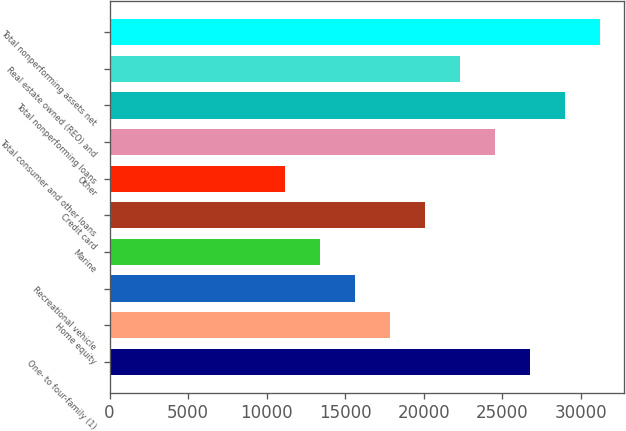Convert chart. <chart><loc_0><loc_0><loc_500><loc_500><bar_chart><fcel>One- to four-family (1)<fcel>Home equity<fcel>Recreational vehicle<fcel>Marine<fcel>Credit card<fcel>Other<fcel>Total consumer and other loans<fcel>Total nonperforming loans<fcel>Real estate owned (REO) and<fcel>Total nonperforming assets net<nl><fcel>26762.4<fcel>17841.6<fcel>15611.4<fcel>13381.2<fcel>20071.8<fcel>11151.1<fcel>24532.2<fcel>28992.6<fcel>22302<fcel>31222.8<nl></chart> 